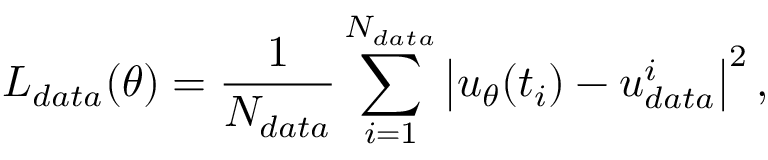Convert formula to latex. <formula><loc_0><loc_0><loc_500><loc_500>L _ { d a t a } ( \theta ) = \frac { 1 } { N _ { d a t a } } \sum _ { i = 1 } ^ { N _ { d a t a } } \left | { u _ { \theta } } ( t _ { i } ) - u _ { d a t a } ^ { i } \right | ^ { 2 } ,</formula> 